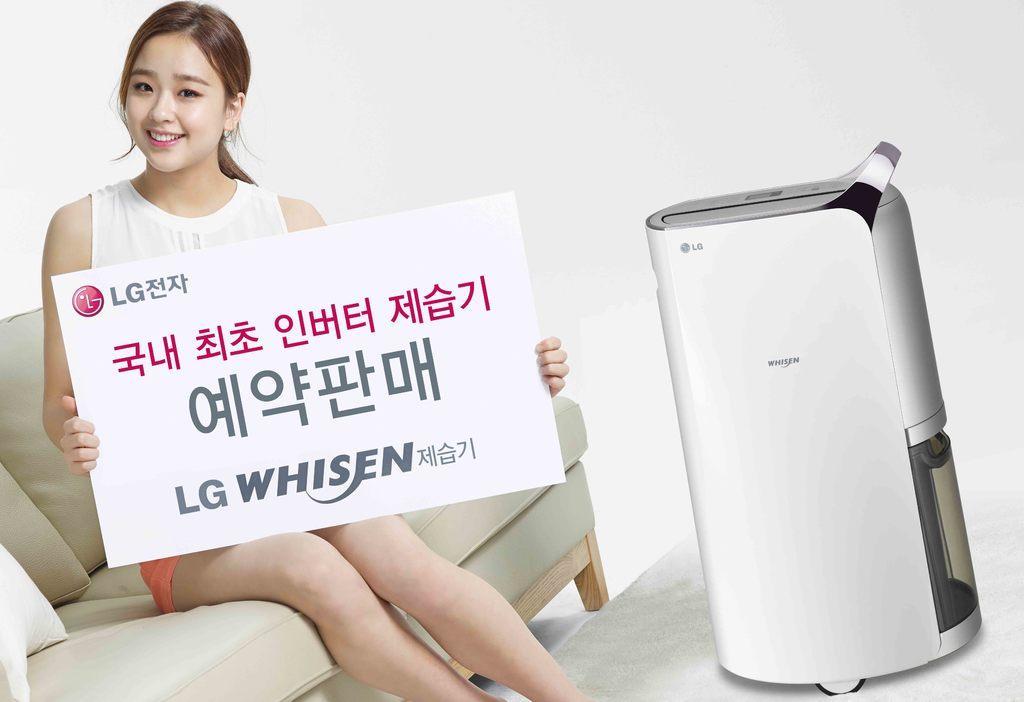How would you summarize this image in a sentence or two? In this picture we can see a woman sitting on a sofa and holding a white board. We can see a logo and some text on this white board. There is a device visible on the right side. Background is white in color. 